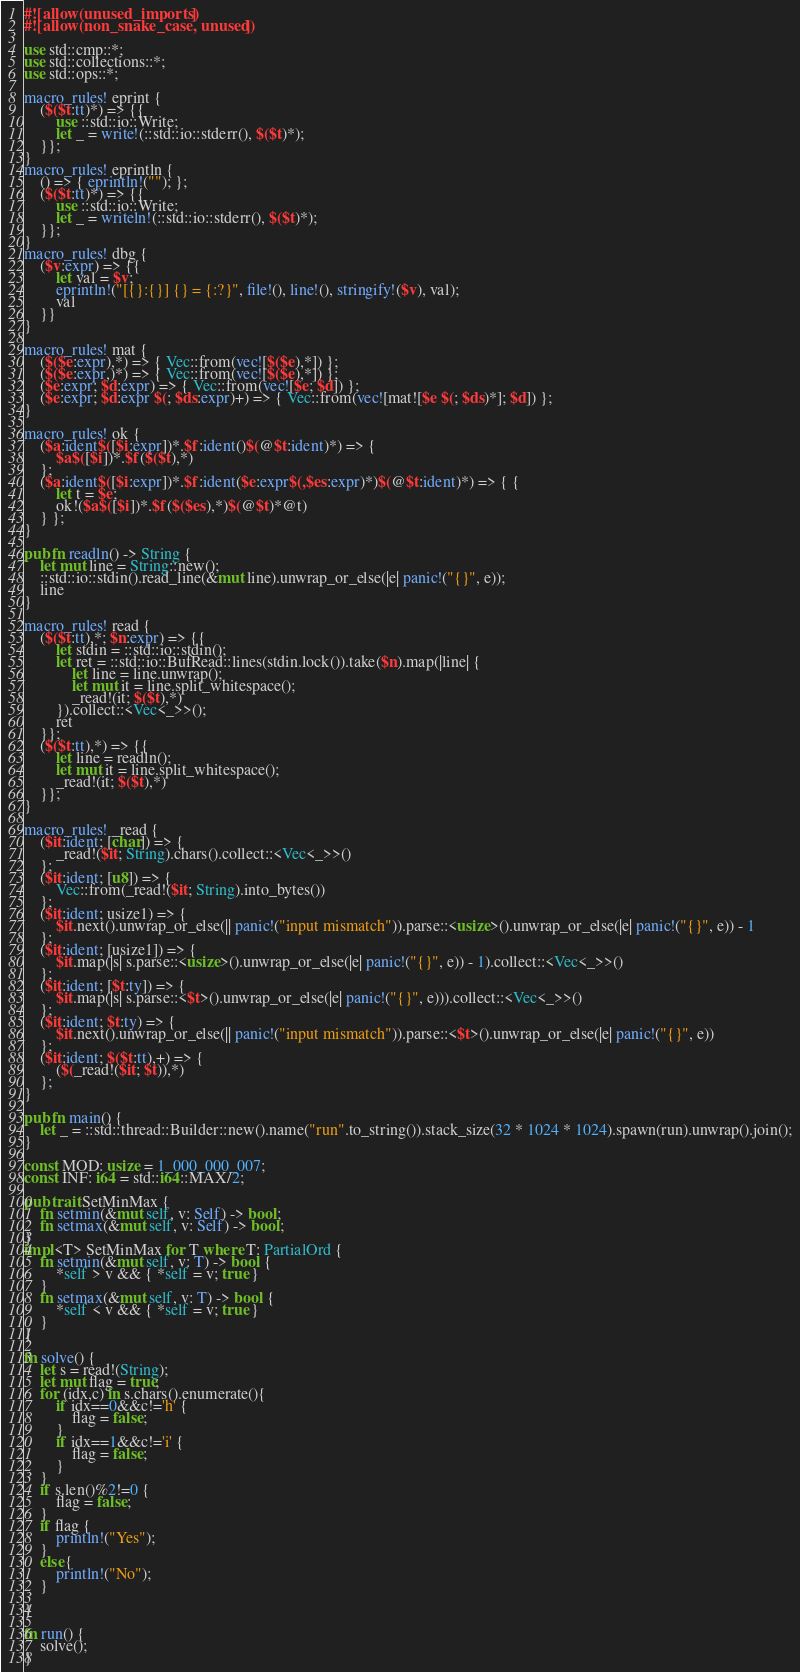<code> <loc_0><loc_0><loc_500><loc_500><_Rust_>#![allow(unused_imports)]
#![allow(non_snake_case, unused)]

use std::cmp::*;
use std::collections::*;
use std::ops::*;

macro_rules! eprint {
	($($t:tt)*) => {{
		use ::std::io::Write;
		let _ = write!(::std::io::stderr(), $($t)*);
	}};
}
macro_rules! eprintln {
	() => { eprintln!(""); };
	($($t:tt)*) => {{
		use ::std::io::Write;
		let _ = writeln!(::std::io::stderr(), $($t)*);
	}};
}
macro_rules! dbg {
	($v:expr) => {{
		let val = $v;
		eprintln!("[{}:{}] {} = {:?}", file!(), line!(), stringify!($v), val);
		val
	}}
}

macro_rules! mat {
	($($e:expr),*) => { Vec::from(vec![$($e),*]) };
	($($e:expr,)*) => { Vec::from(vec![$($e),*]) };
	($e:expr; $d:expr) => { Vec::from(vec![$e; $d]) };
	($e:expr; $d:expr $(; $ds:expr)+) => { Vec::from(vec![mat![$e $(; $ds)*]; $d]) };
}

macro_rules! ok {
	($a:ident$([$i:expr])*.$f:ident()$(@$t:ident)*) => {
		$a$([$i])*.$f($($t),*)
	};
	($a:ident$([$i:expr])*.$f:ident($e:expr$(,$es:expr)*)$(@$t:ident)*) => { {
		let t = $e;
		ok!($a$([$i])*.$f($($es),*)$(@$t)*@t)
	} };
}

pub fn readln() -> String {
	let mut line = String::new();
	::std::io::stdin().read_line(&mut line).unwrap_or_else(|e| panic!("{}", e));
	line
}

macro_rules! read {
	($($t:tt),*; $n:expr) => {{
		let stdin = ::std::io::stdin();
		let ret = ::std::io::BufRead::lines(stdin.lock()).take($n).map(|line| {
			let line = line.unwrap();
			let mut it = line.split_whitespace();
			_read!(it; $($t),*)
		}).collect::<Vec<_>>();
		ret
	}};
	($($t:tt),*) => {{
		let line = readln();
		let mut it = line.split_whitespace();
		_read!(it; $($t),*)
	}};
}

macro_rules! _read {
	($it:ident; [char]) => {
		_read!($it; String).chars().collect::<Vec<_>>()
	};
	($it:ident; [u8]) => {
		Vec::from(_read!($it; String).into_bytes())
	};
	($it:ident; usize1) => {
		$it.next().unwrap_or_else(|| panic!("input mismatch")).parse::<usize>().unwrap_or_else(|e| panic!("{}", e)) - 1
	};
	($it:ident; [usize1]) => {
		$it.map(|s| s.parse::<usize>().unwrap_or_else(|e| panic!("{}", e)) - 1).collect::<Vec<_>>()
	};
	($it:ident; [$t:ty]) => {
		$it.map(|s| s.parse::<$t>().unwrap_or_else(|e| panic!("{}", e))).collect::<Vec<_>>()
	};
	($it:ident; $t:ty) => {
		$it.next().unwrap_or_else(|| panic!("input mismatch")).parse::<$t>().unwrap_or_else(|e| panic!("{}", e))
	};
	($it:ident; $($t:tt),+) => {
		($(_read!($it; $t)),*)
	};
}

pub fn main() {
	let _ = ::std::thread::Builder::new().name("run".to_string()).stack_size(32 * 1024 * 1024).spawn(run).unwrap().join();
}

const MOD: usize = 1_000_000_007;
const INF: i64 = std::i64::MAX/2;

pub trait SetMinMax {
	fn setmin(&mut self, v: Self) -> bool;
	fn setmax(&mut self, v: Self) -> bool;
}
impl<T> SetMinMax for T where T: PartialOrd {
	fn setmin(&mut self, v: T) -> bool {
		*self > v && { *self = v; true }
	}
	fn setmax(&mut self, v: T) -> bool {
		*self < v && { *self = v; true }
	}
}

fn solve() {
	let s = read!(String);
	let mut flag = true;
	for (idx,c) in s.chars().enumerate(){
		if idx==0&&c!='h' {
			flag = false;
		}
		if idx==1&&c!='i' {
			flag = false;
		}
	}
	if s.len()%2!=0 {
		flag = false;
	}
	if flag {
		println!("Yes");
	}
	else{
		println!("No");
	}
	
}

fn run() {
    solve();
}
</code> 